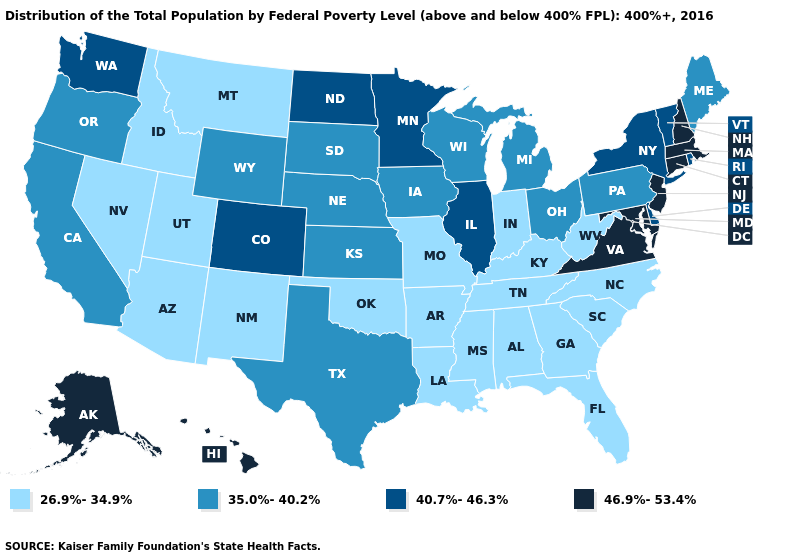Is the legend a continuous bar?
Quick response, please. No. Does Texas have a higher value than Colorado?
Answer briefly. No. Name the states that have a value in the range 35.0%-40.2%?
Be succinct. California, Iowa, Kansas, Maine, Michigan, Nebraska, Ohio, Oregon, Pennsylvania, South Dakota, Texas, Wisconsin, Wyoming. Among the states that border Delaware , which have the highest value?
Quick response, please. Maryland, New Jersey. What is the lowest value in the USA?
Short answer required. 26.9%-34.9%. What is the value of Maryland?
Quick response, please. 46.9%-53.4%. Which states have the lowest value in the USA?
Answer briefly. Alabama, Arizona, Arkansas, Florida, Georgia, Idaho, Indiana, Kentucky, Louisiana, Mississippi, Missouri, Montana, Nevada, New Mexico, North Carolina, Oklahoma, South Carolina, Tennessee, Utah, West Virginia. Does Pennsylvania have the lowest value in the Northeast?
Answer briefly. Yes. Name the states that have a value in the range 35.0%-40.2%?
Be succinct. California, Iowa, Kansas, Maine, Michigan, Nebraska, Ohio, Oregon, Pennsylvania, South Dakota, Texas, Wisconsin, Wyoming. What is the value of Hawaii?
Quick response, please. 46.9%-53.4%. Among the states that border Connecticut , which have the lowest value?
Give a very brief answer. New York, Rhode Island. Among the states that border California , does Nevada have the lowest value?
Quick response, please. Yes. Does Arizona have the highest value in the West?
Concise answer only. No. Does Maryland have the lowest value in the South?
Short answer required. No. What is the highest value in the West ?
Concise answer only. 46.9%-53.4%. 